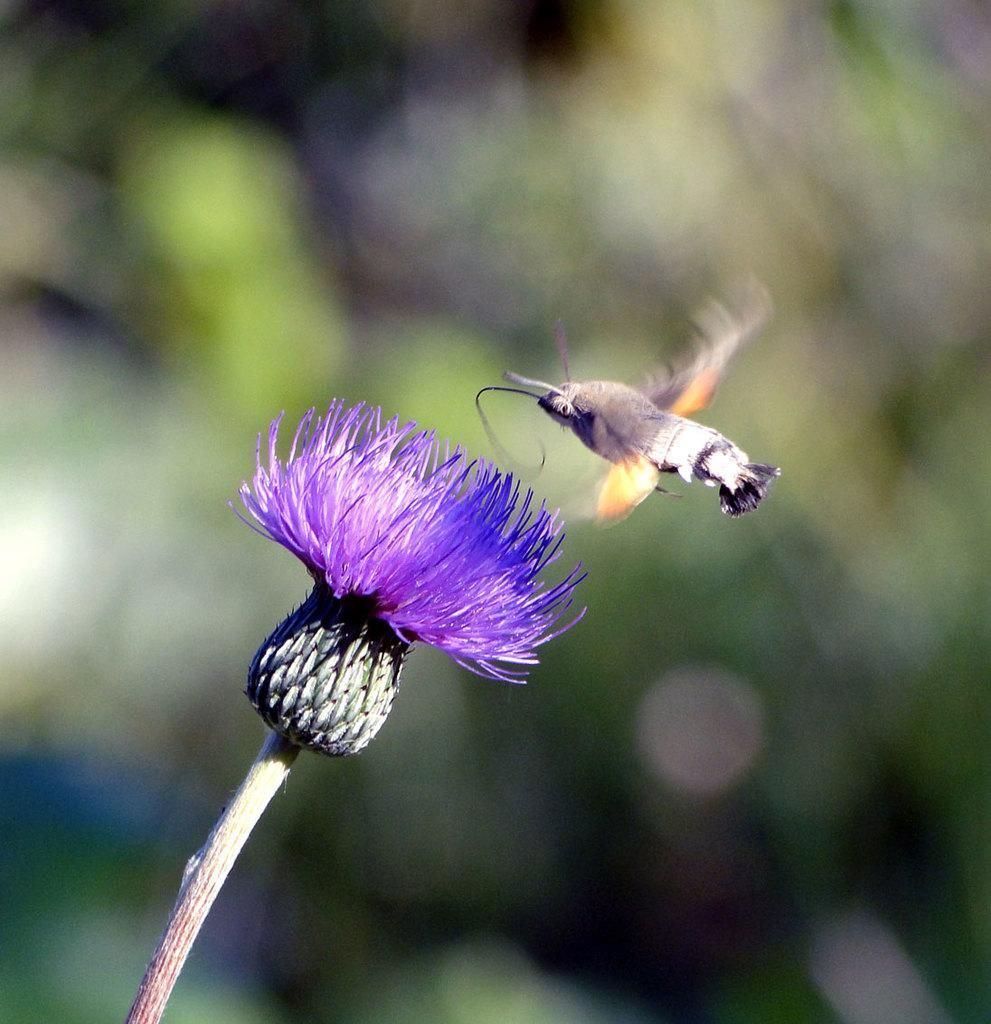In one or two sentences, can you explain what this image depicts? In this image there is a fly on a flower with stem. The background is blurred. 